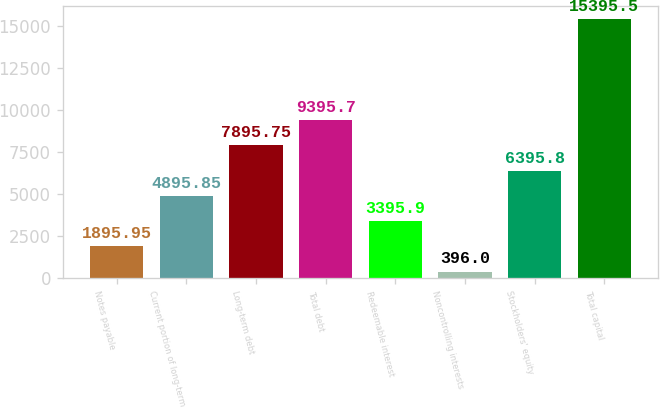Convert chart to OTSL. <chart><loc_0><loc_0><loc_500><loc_500><bar_chart><fcel>Notes payable<fcel>Current portion of long-term<fcel>Long-term debt<fcel>Total debt<fcel>Redeemable interest<fcel>Noncontrolling interests<fcel>Stockholders' equity<fcel>Total capital<nl><fcel>1895.95<fcel>4895.85<fcel>7895.75<fcel>9395.7<fcel>3395.9<fcel>396<fcel>6395.8<fcel>15395.5<nl></chart> 